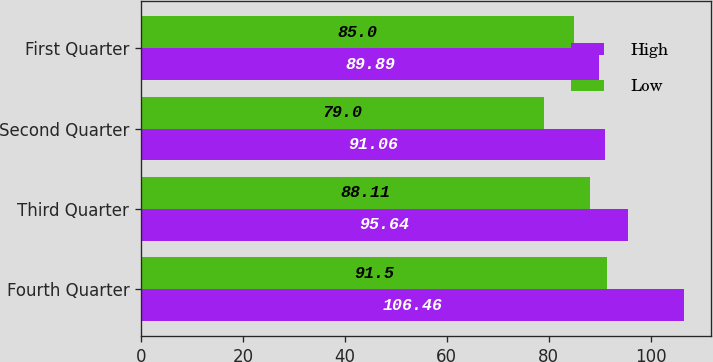Convert chart to OTSL. <chart><loc_0><loc_0><loc_500><loc_500><stacked_bar_chart><ecel><fcel>Fourth Quarter<fcel>Third Quarter<fcel>Second Quarter<fcel>First Quarter<nl><fcel>High<fcel>106.46<fcel>95.64<fcel>91.06<fcel>89.89<nl><fcel>Low<fcel>91.5<fcel>88.11<fcel>79<fcel>85<nl></chart> 